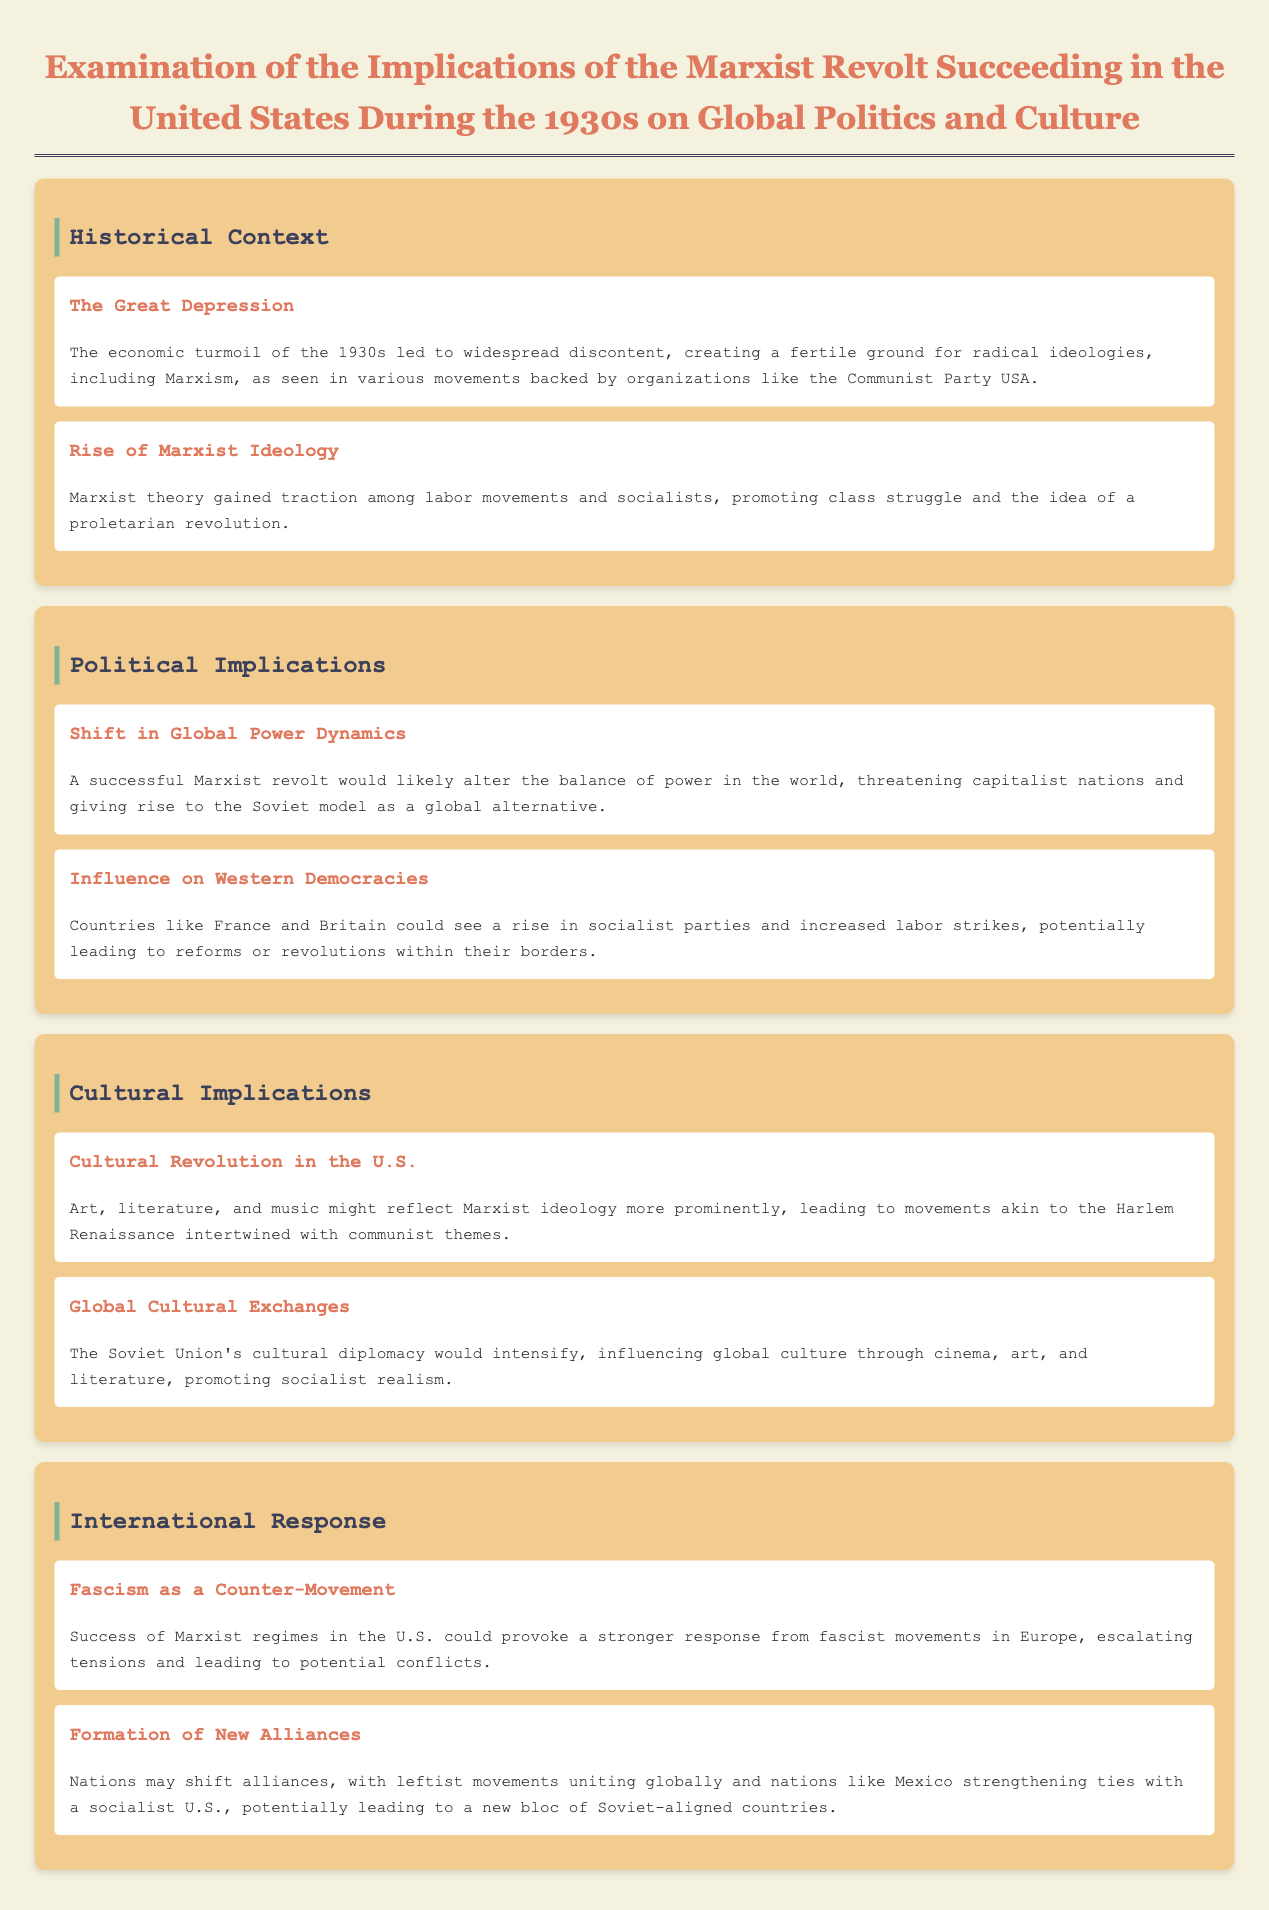What event created fertile ground for radical ideologies? The document states that the economic turmoil of the 1930s led to widespread discontent, which created a fertile ground for radical ideologies, including Marxism.
Answer: The Great Depression What two countries could see a rise in socialist parties? The document mentions that countries like France and Britain could see an increase in socialist parties and labor strikes.
Answer: France and Britain What major cultural movement might intertwine with communist themes? The document suggests that the Harlem Renaissance may reflect Marxist ideology more prominently.
Answer: Harlem Renaissance Which country might strengthen ties with a socialist U.S.? The document indicates that Mexico may strengthen ties with a socialist U.S.
Answer: Mexico What type of counter-movement could rise in response to Marxist regimes? According to the document, if Marxist regimes succeed in the U.S., it could provoke a stronger response from fascist movements.
Answer: Fascism What might art and literature reflect if Marxism succeeded in the U.S.? The document states that art, literature, and music might reflect Marxist ideology more prominently.
Answer: Marxist ideology What would likely be altered by a successful Marxist revolt? The document mentions that a successful Marxist revolt would likely alter the balance of power in the world.
Answer: Global power dynamics Which ideology gained traction among labor movements in the 1930s? The document specifically notes that Marxist theory gained traction among labor movements and socialists.
Answer: Marxism What type of diplomacy would intensify according to the document? The document states that the Soviet Union's cultural diplomacy would intensify as a result of a U.S. Marxist revolt.
Answer: Cultural diplomacy 